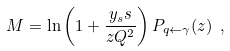<formula> <loc_0><loc_0><loc_500><loc_500>M = \ln \left ( 1 + \frac { y _ { s } s } { z Q ^ { 2 } } \right ) P _ { q \leftarrow \gamma } ( z ) \ ,</formula> 